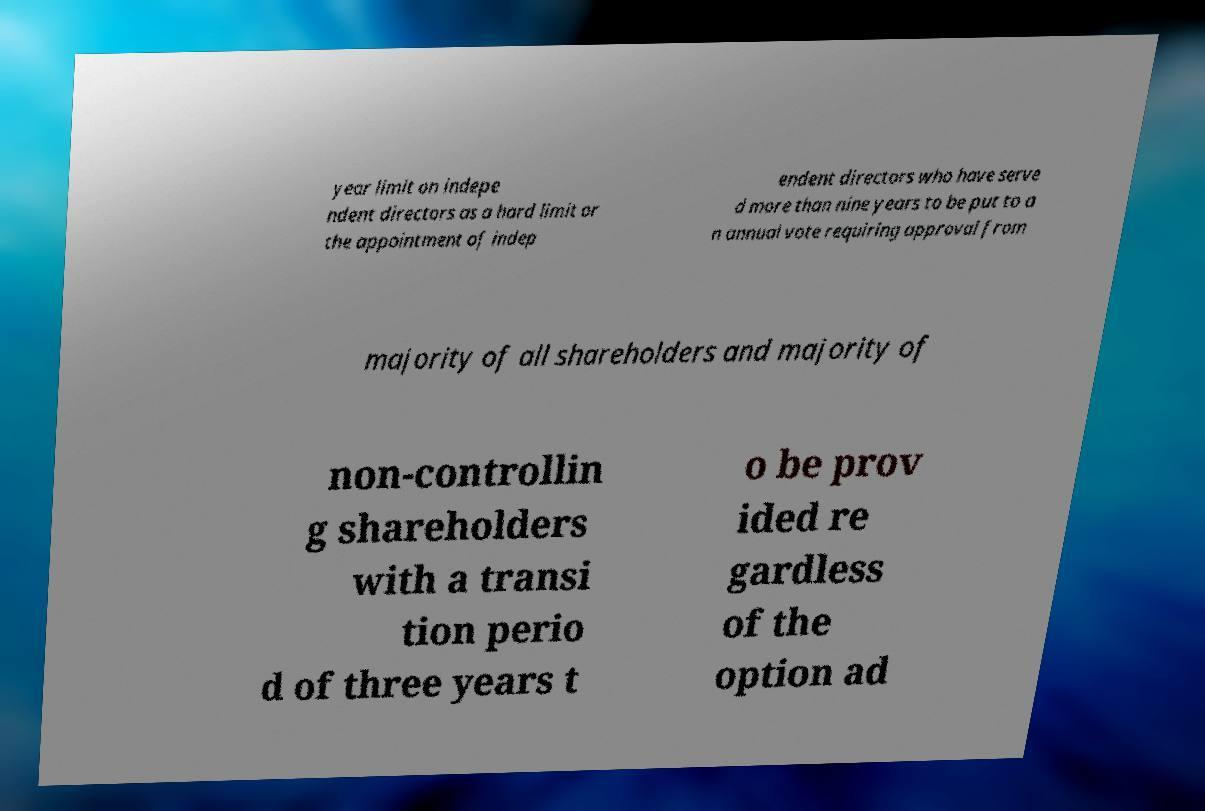Please read and relay the text visible in this image. What does it say? year limit on indepe ndent directors as a hard limit or the appointment of indep endent directors who have serve d more than nine years to be put to a n annual vote requiring approval from majority of all shareholders and majority of non-controllin g shareholders with a transi tion perio d of three years t o be prov ided re gardless of the option ad 